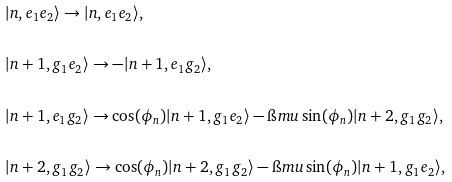Convert formula to latex. <formula><loc_0><loc_0><loc_500><loc_500>& | n , e _ { 1 } e _ { 2 } \rangle \rightarrow | n , e _ { 1 } e _ { 2 } \rangle , \\ \\ & | n + 1 , g _ { 1 } e _ { 2 } \rangle \rightarrow - | n + 1 , e _ { 1 } g _ { 2 } \rangle , \\ \\ & | n + 1 , e _ { 1 } g _ { 2 } \rangle \rightarrow \cos ( \phi _ { n } ) | n + 1 , g _ { 1 } e _ { 2 } \rangle - \i m u \sin ( \phi _ { n } ) | n + 2 , g _ { 1 } g _ { 2 } \rangle , \\ \\ & | n + 2 , g _ { 1 } g _ { 2 } \rangle \rightarrow \cos ( \phi _ { n } ) | n + 2 , g _ { 1 } g _ { 2 } \rangle - \i m u \sin ( \phi _ { n } ) | n + 1 , g _ { 1 } e _ { 2 } \rangle ,</formula> 